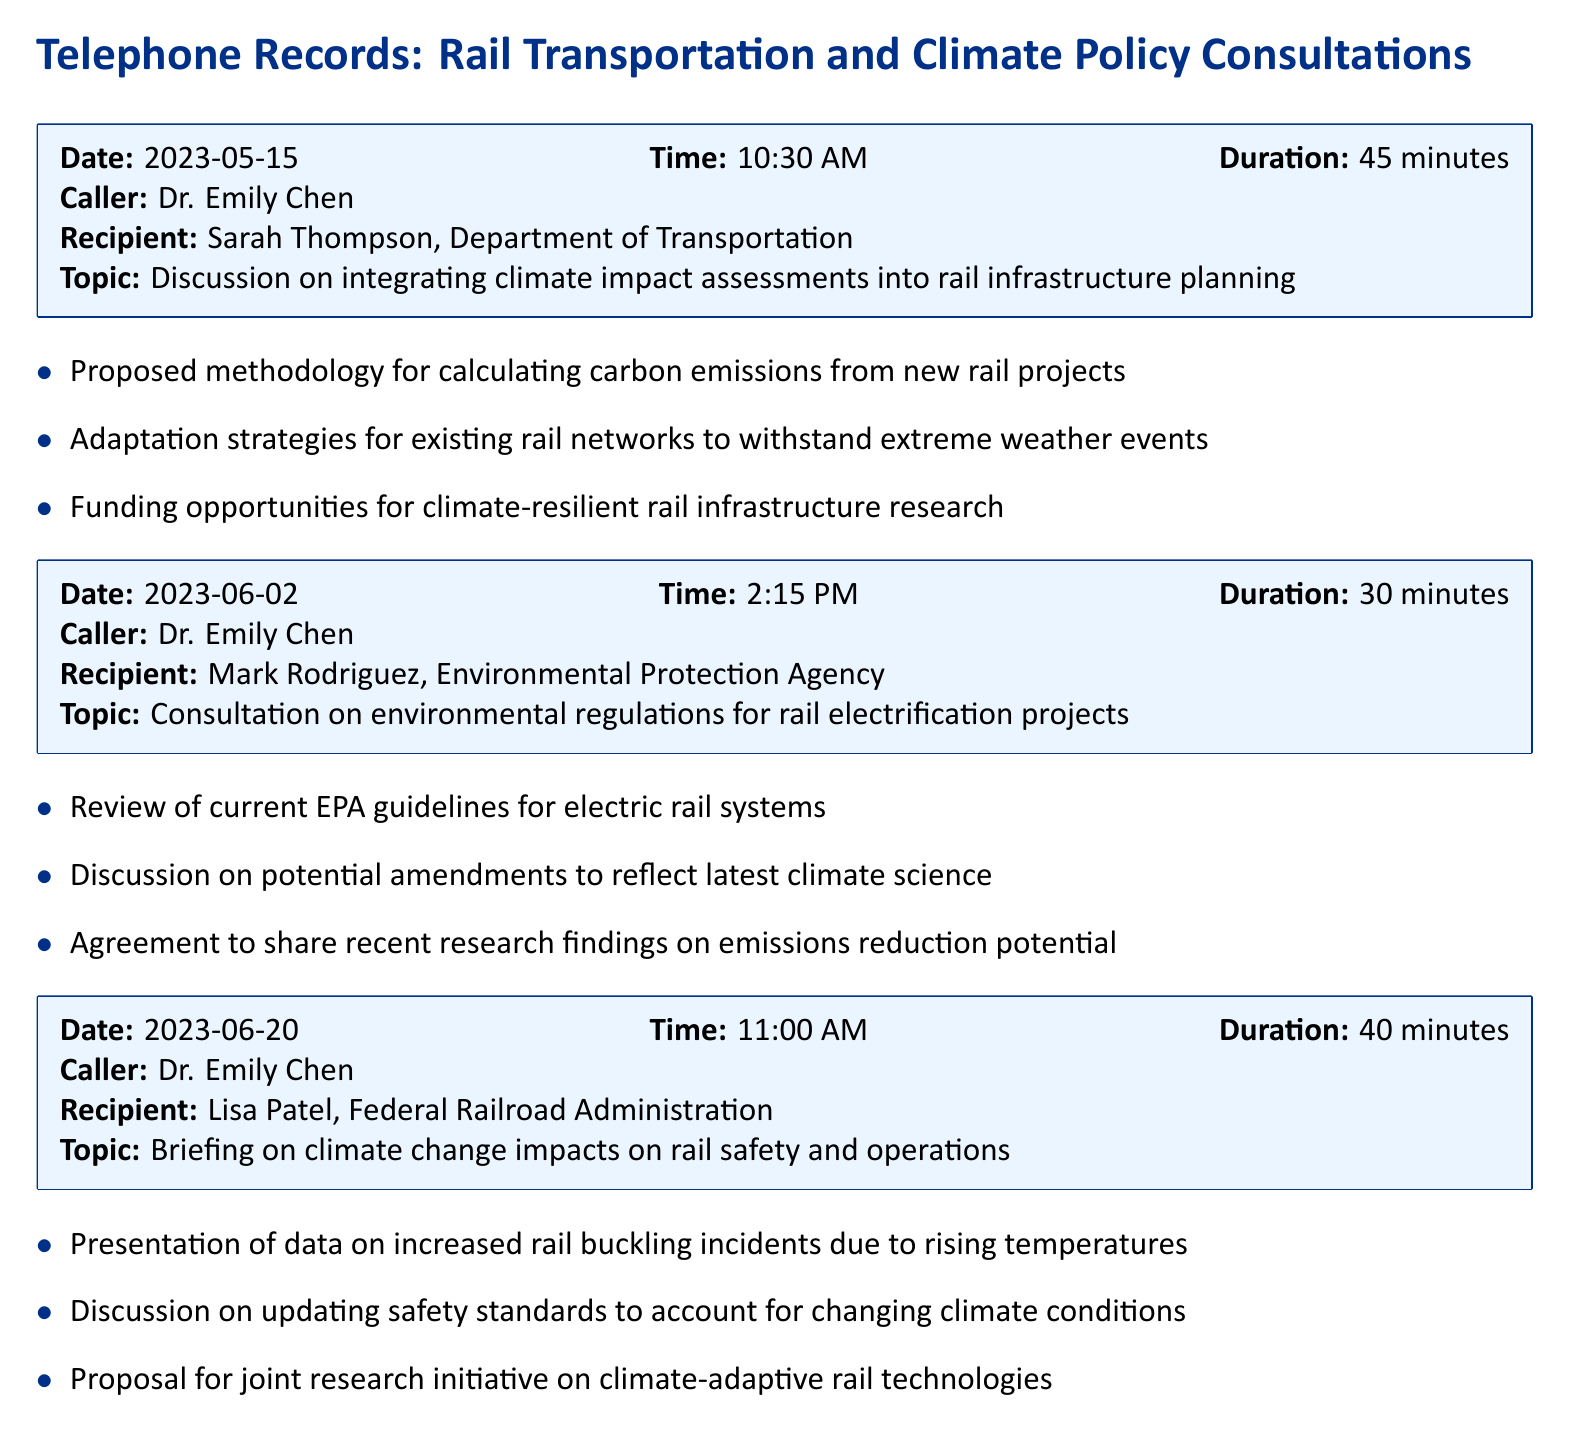What is the date of the consultation with the Department of Transportation? The date of the consultation is specified in the first record entry.
Answer: 2023-05-15 Who was the recipient in the consultation on environmental regulations? The recipient is mentioned in the second record entry.
Answer: Mark Rodriguez, Environmental Protection Agency How long did the briefing on climate change impacts on rail safety last? The duration of the briefing is included in the third record entry.
Answer: 40 minutes What methodology was proposed in the May consultation? The proposed methodology is listed as a key point in the first record entry.
Answer: Calculating carbon emissions from new rail projects What is one theme discussed in the consultation with Lisa Patel? The discussion themes are summarized in the key points of the third record.
Answer: Climate change impacts on rail safety and operations What was one of the funding opportunities mentioned in the May consultation? The funding opportunities are detailed in the key points of the first record entry.
Answer: Climate-resilient rail infrastructure research What is the time of the consultation with the Environmental Protection Agency? The time for the consultation is provided in the second record entry.
Answer: 2:15 PM What type of technology was proposed for joint research in the June consultation? The document refers to the type of technology within the key points for the final consultation.
Answer: Climate-adaptive rail technologies 